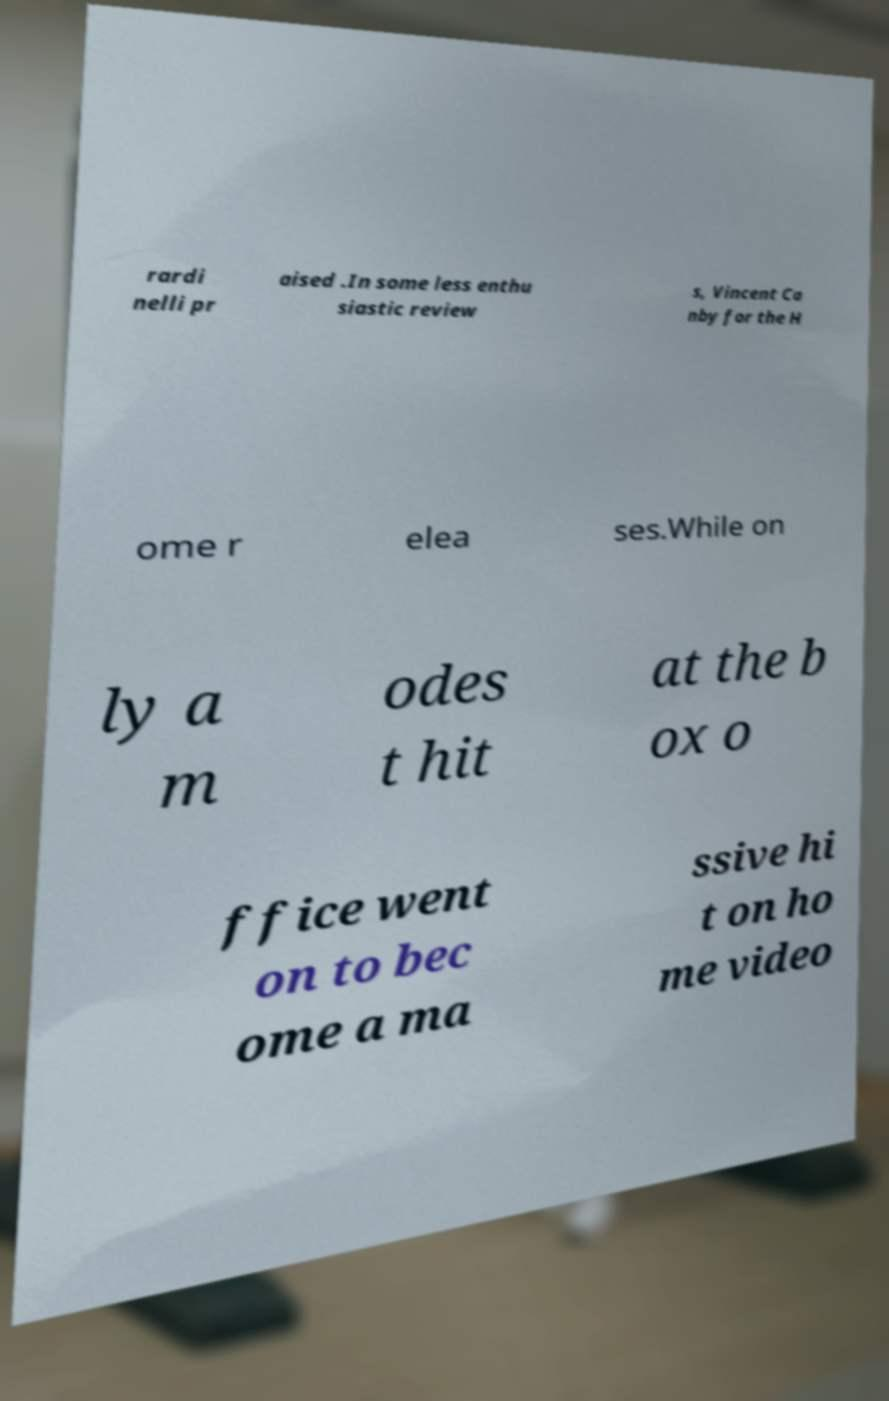What messages or text are displayed in this image? I need them in a readable, typed format. rardi nelli pr aised .In some less enthu siastic review s, Vincent Ca nby for the H ome r elea ses.While on ly a m odes t hit at the b ox o ffice went on to bec ome a ma ssive hi t on ho me video 